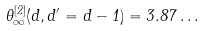<formula> <loc_0><loc_0><loc_500><loc_500>\theta _ { \infty } ^ { [ 2 ] } ( d , d ^ { \prime } = d - 1 ) = 3 . 8 7 \dots</formula> 